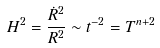<formula> <loc_0><loc_0><loc_500><loc_500>H ^ { 2 } = \frac { \dot { R } ^ { 2 } } { R ^ { 2 } } \sim t ^ { - 2 } = T ^ { n + 2 }</formula> 